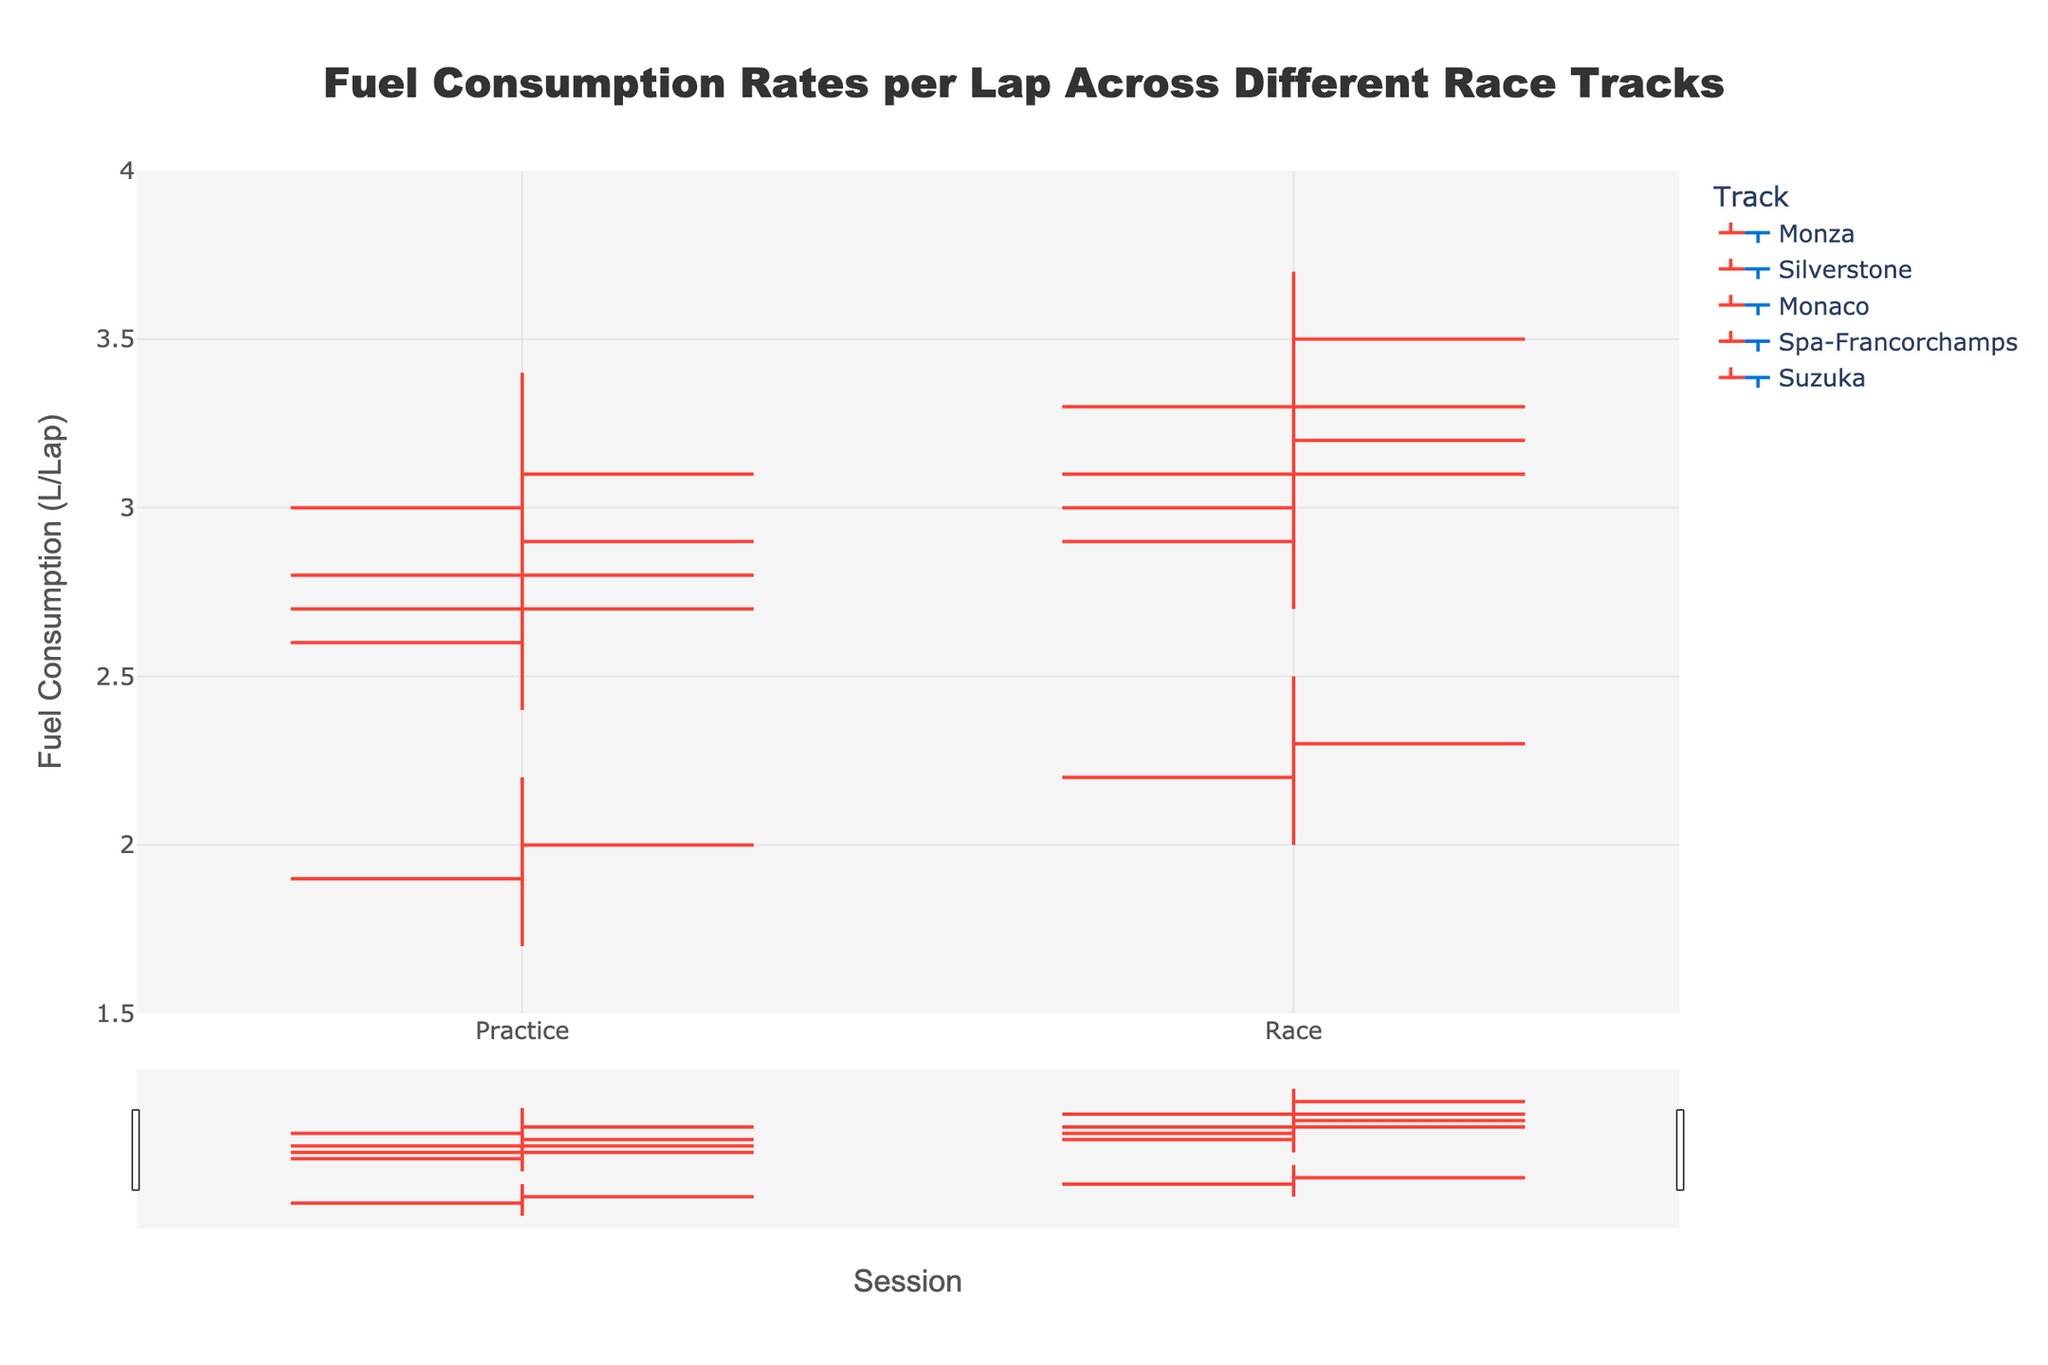What's the title of the figure? The title is usually displayed prominently at the top of the figure in larger font size. It summarizes the main topic or data presented in the chart.
Answer: Fuel Consumption Rates per Lap Across Different Race Tracks What are the sessions compared in the figure? The sessions are usually labeled on the x-axis of the plot. By examining these labels, we can see that two different sessions are compared.
Answer: Practice and Race Which track has the highest maximum fuel consumption during race day? By examining the "High" values for the "Race" session on each track, we can identify the track with the highest peak. The highest value corresponds to Spa-Francorchamps with a high of 3.7 L/lap.
Answer: Spa-Francorchamps What is the average closing fuel consumption for practice sessions across all tracks? Calculate the average of the "Close" fuel consumption values for the "Practice" session across all tracks: (2.9 + 2.7 + 2.0 + 3.1 + 2.8) / 5 = 2.7 L/lap.
Answer: 2.7 L/lap Which track shows the least difference in fuel consumption between practice and race day in terms of close values? Calculate the difference in "Close" values between "Practice" and "Race" for each track and identify the smallest difference. The differences are Monza (0.4), Silverstone (0.4), Monaco (0.3), Spa-Francorchamps (0.4), and Suzuka (0.4). Hence, Monaco has the smallest difference.
Answer: Monaco How does the consumption rate typically change from practice to race day across different tracks? By comparing the "Close" values of each track for both sessions: Monza (2.9 to 3.3), Silverstone (2.7 to 3.1), Monaco (2.0 to 2.3), Spa-Francorchamps (3.1 to 3.5), Suzuka (2.8 to 3.2), we can observe that the fuel consumption rate generally increases from practice to race day.
Answer: It increases Which session shows more variability in fuel consumption across all tracks, practice or race day? Compare the ranges (High - Low) for both sessions across all tracks and sum them to determine the variability. Practice: (3.2-2.6) + (3.0-2.4) + (2.2-1.7) + (3.4-2.8) + (3.1-2.5) = 3.4. Race: (3.5-2.9) + (3.3-2.7) + (2.5-2.0) + (3.7-3.1) + (3.4-2.8) = 4.1. Hence, race day shows more variability in fuel consumption.
Answer: Race day What's the average high value of fuel consumption for race days across all tracks? Calculate the average of the "High" values for the "Race" sessions: (3.5 + 3.3 + 2.5 + 3.7 + 3.4) / 5 = 3.28 L/lap
Answer: 3.28 L/lap What's the maximum low value of fuel consumption across all tracks and sessions? Identify the highest "Low" value among all the tracks and sessions: Monza (2.6/2.9), Silverstone (2.4/2.7), Monaco (1.7/2.0), Spa-Francorchamps (2.8/3.1), Suzuka (2.5/2.8). The maximum low value is 3.1 for Spa-Francorchamps during the race session.
Answer: 3.1 